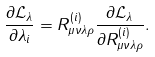Convert formula to latex. <formula><loc_0><loc_0><loc_500><loc_500>\frac { \partial \mathcal { L } _ { \lambda } } { \partial \lambda _ { i } } = R _ { \mu \nu \lambda \rho } ^ { ( i ) } \frac { \partial \mathcal { L } _ { \lambda } } { \partial R _ { \mu \nu \lambda \rho } ^ { ( i ) } } .</formula> 